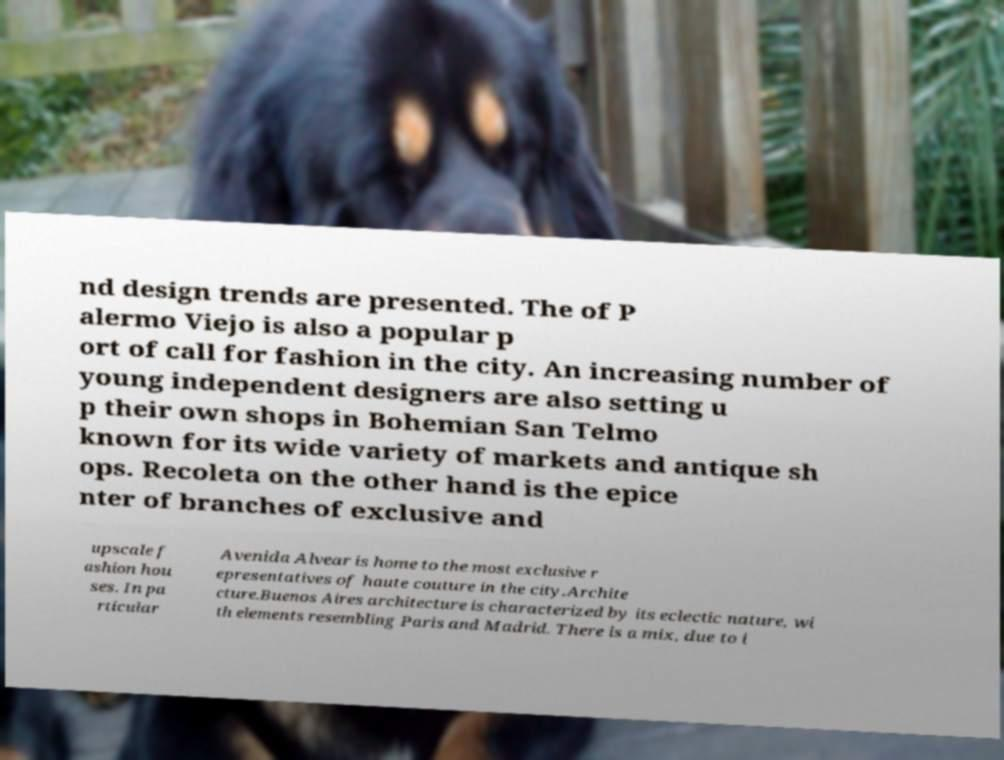Can you read and provide the text displayed in the image?This photo seems to have some interesting text. Can you extract and type it out for me? nd design trends are presented. The of P alermo Viejo is also a popular p ort of call for fashion in the city. An increasing number of young independent designers are also setting u p their own shops in Bohemian San Telmo known for its wide variety of markets and antique sh ops. Recoleta on the other hand is the epice nter of branches of exclusive and upscale f ashion hou ses. In pa rticular Avenida Alvear is home to the most exclusive r epresentatives of haute couture in the city.Archite cture.Buenos Aires architecture is characterized by its eclectic nature, wi th elements resembling Paris and Madrid. There is a mix, due to i 